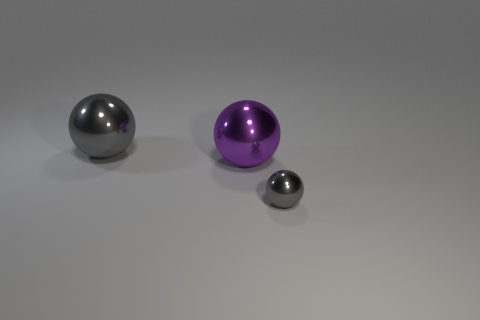There is a ball that is the same color as the small shiny thing; what is its material?
Ensure brevity in your answer.  Metal. There is a tiny shiny thing; does it have the same color as the object that is on the left side of the big purple ball?
Provide a succinct answer. Yes. Is the number of gray metal spheres that are to the left of the large gray thing greater than the number of large purple balls?
Keep it short and to the point. No. There is a gray metallic sphere that is to the right of the gray metallic sphere that is on the left side of the small thing; what number of gray things are to the left of it?
Give a very brief answer. 1. There is a large thing that is behind the big purple metallic sphere; does it have the same shape as the small gray object?
Your response must be concise. Yes. What is the gray object right of the purple metal object made of?
Your answer should be compact. Metal. What is the tiny gray sphere made of?
Your answer should be compact. Metal. What number of blocks are either red matte things or large gray things?
Offer a terse response. 0. Do the tiny ball and the large purple ball have the same material?
Your answer should be very brief. Yes. There is a purple shiny thing that is the same shape as the tiny gray shiny object; what is its size?
Provide a short and direct response. Large. 